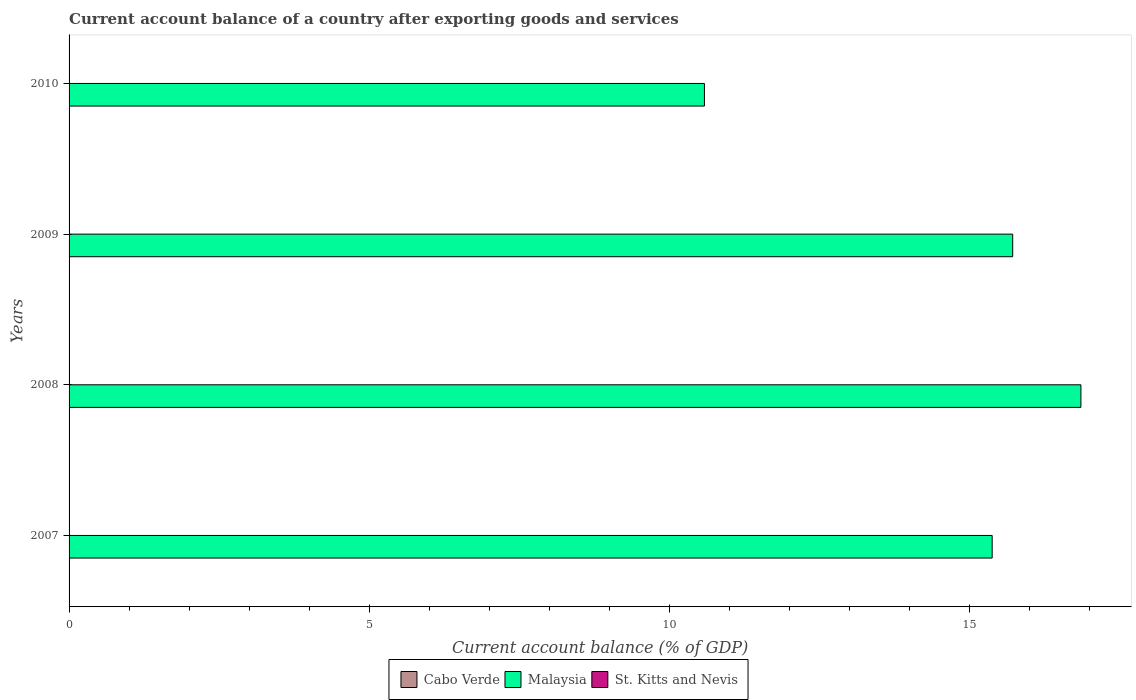How many different coloured bars are there?
Your answer should be very brief. 1. Are the number of bars on each tick of the Y-axis equal?
Keep it short and to the point. Yes. In how many cases, is the number of bars for a given year not equal to the number of legend labels?
Ensure brevity in your answer.  4. What is the account balance in St. Kitts and Nevis in 2010?
Provide a short and direct response. 0. Across all years, what is the maximum account balance in Malaysia?
Offer a very short reply. 16.86. Across all years, what is the minimum account balance in Malaysia?
Your response must be concise. 10.59. In which year was the account balance in Malaysia maximum?
Provide a short and direct response. 2008. What is the total account balance in Cabo Verde in the graph?
Provide a succinct answer. 0. What is the difference between the account balance in Malaysia in 2007 and that in 2010?
Offer a terse response. 4.79. What is the difference between the account balance in Cabo Verde in 2010 and the account balance in Malaysia in 2008?
Your answer should be very brief. -16.86. What is the average account balance in Cabo Verde per year?
Ensure brevity in your answer.  0. What is the ratio of the account balance in Malaysia in 2007 to that in 2008?
Ensure brevity in your answer.  0.91. Is the account balance in Malaysia in 2007 less than that in 2008?
Keep it short and to the point. Yes. What is the difference between the highest and the second highest account balance in Malaysia?
Keep it short and to the point. 1.14. What is the difference between the highest and the lowest account balance in Malaysia?
Provide a succinct answer. 6.27. Is it the case that in every year, the sum of the account balance in Cabo Verde and account balance in St. Kitts and Nevis is greater than the account balance in Malaysia?
Give a very brief answer. No. How many bars are there?
Your answer should be compact. 4. How many years are there in the graph?
Offer a terse response. 4. What is the difference between two consecutive major ticks on the X-axis?
Your response must be concise. 5. Are the values on the major ticks of X-axis written in scientific E-notation?
Keep it short and to the point. No. Does the graph contain any zero values?
Provide a short and direct response. Yes. How many legend labels are there?
Ensure brevity in your answer.  3. What is the title of the graph?
Offer a very short reply. Current account balance of a country after exporting goods and services. Does "Vietnam" appear as one of the legend labels in the graph?
Provide a short and direct response. No. What is the label or title of the X-axis?
Provide a short and direct response. Current account balance (% of GDP). What is the label or title of the Y-axis?
Provide a succinct answer. Years. What is the Current account balance (% of GDP) in Malaysia in 2007?
Make the answer very short. 15.38. What is the Current account balance (% of GDP) in St. Kitts and Nevis in 2007?
Keep it short and to the point. 0. What is the Current account balance (% of GDP) in Cabo Verde in 2008?
Give a very brief answer. 0. What is the Current account balance (% of GDP) in Malaysia in 2008?
Your answer should be compact. 16.86. What is the Current account balance (% of GDP) of St. Kitts and Nevis in 2008?
Give a very brief answer. 0. What is the Current account balance (% of GDP) of Malaysia in 2009?
Offer a terse response. 15.72. What is the Current account balance (% of GDP) in Malaysia in 2010?
Provide a succinct answer. 10.59. Across all years, what is the maximum Current account balance (% of GDP) of Malaysia?
Ensure brevity in your answer.  16.86. Across all years, what is the minimum Current account balance (% of GDP) in Malaysia?
Give a very brief answer. 10.59. What is the total Current account balance (% of GDP) of Malaysia in the graph?
Your response must be concise. 58.55. What is the total Current account balance (% of GDP) of St. Kitts and Nevis in the graph?
Provide a succinct answer. 0. What is the difference between the Current account balance (% of GDP) in Malaysia in 2007 and that in 2008?
Offer a terse response. -1.48. What is the difference between the Current account balance (% of GDP) of Malaysia in 2007 and that in 2009?
Provide a succinct answer. -0.34. What is the difference between the Current account balance (% of GDP) of Malaysia in 2007 and that in 2010?
Offer a very short reply. 4.79. What is the difference between the Current account balance (% of GDP) of Malaysia in 2008 and that in 2009?
Give a very brief answer. 1.14. What is the difference between the Current account balance (% of GDP) of Malaysia in 2008 and that in 2010?
Offer a very short reply. 6.27. What is the difference between the Current account balance (% of GDP) in Malaysia in 2009 and that in 2010?
Provide a short and direct response. 5.14. What is the average Current account balance (% of GDP) of Cabo Verde per year?
Your response must be concise. 0. What is the average Current account balance (% of GDP) of Malaysia per year?
Ensure brevity in your answer.  14.64. What is the ratio of the Current account balance (% of GDP) of Malaysia in 2007 to that in 2008?
Provide a short and direct response. 0.91. What is the ratio of the Current account balance (% of GDP) in Malaysia in 2007 to that in 2009?
Give a very brief answer. 0.98. What is the ratio of the Current account balance (% of GDP) in Malaysia in 2007 to that in 2010?
Your answer should be very brief. 1.45. What is the ratio of the Current account balance (% of GDP) in Malaysia in 2008 to that in 2009?
Your answer should be very brief. 1.07. What is the ratio of the Current account balance (% of GDP) of Malaysia in 2008 to that in 2010?
Make the answer very short. 1.59. What is the ratio of the Current account balance (% of GDP) in Malaysia in 2009 to that in 2010?
Make the answer very short. 1.49. What is the difference between the highest and the second highest Current account balance (% of GDP) in Malaysia?
Offer a very short reply. 1.14. What is the difference between the highest and the lowest Current account balance (% of GDP) in Malaysia?
Your answer should be very brief. 6.27. 